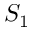Convert formula to latex. <formula><loc_0><loc_0><loc_500><loc_500>S _ { 1 }</formula> 